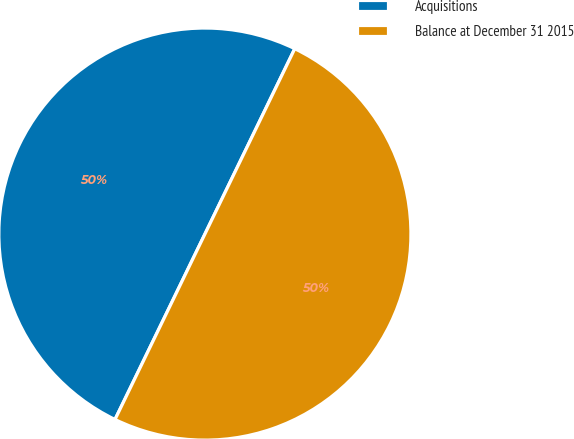<chart> <loc_0><loc_0><loc_500><loc_500><pie_chart><fcel>Acquisitions<fcel>Balance at December 31 2015<nl><fcel>50.0%<fcel>50.0%<nl></chart> 